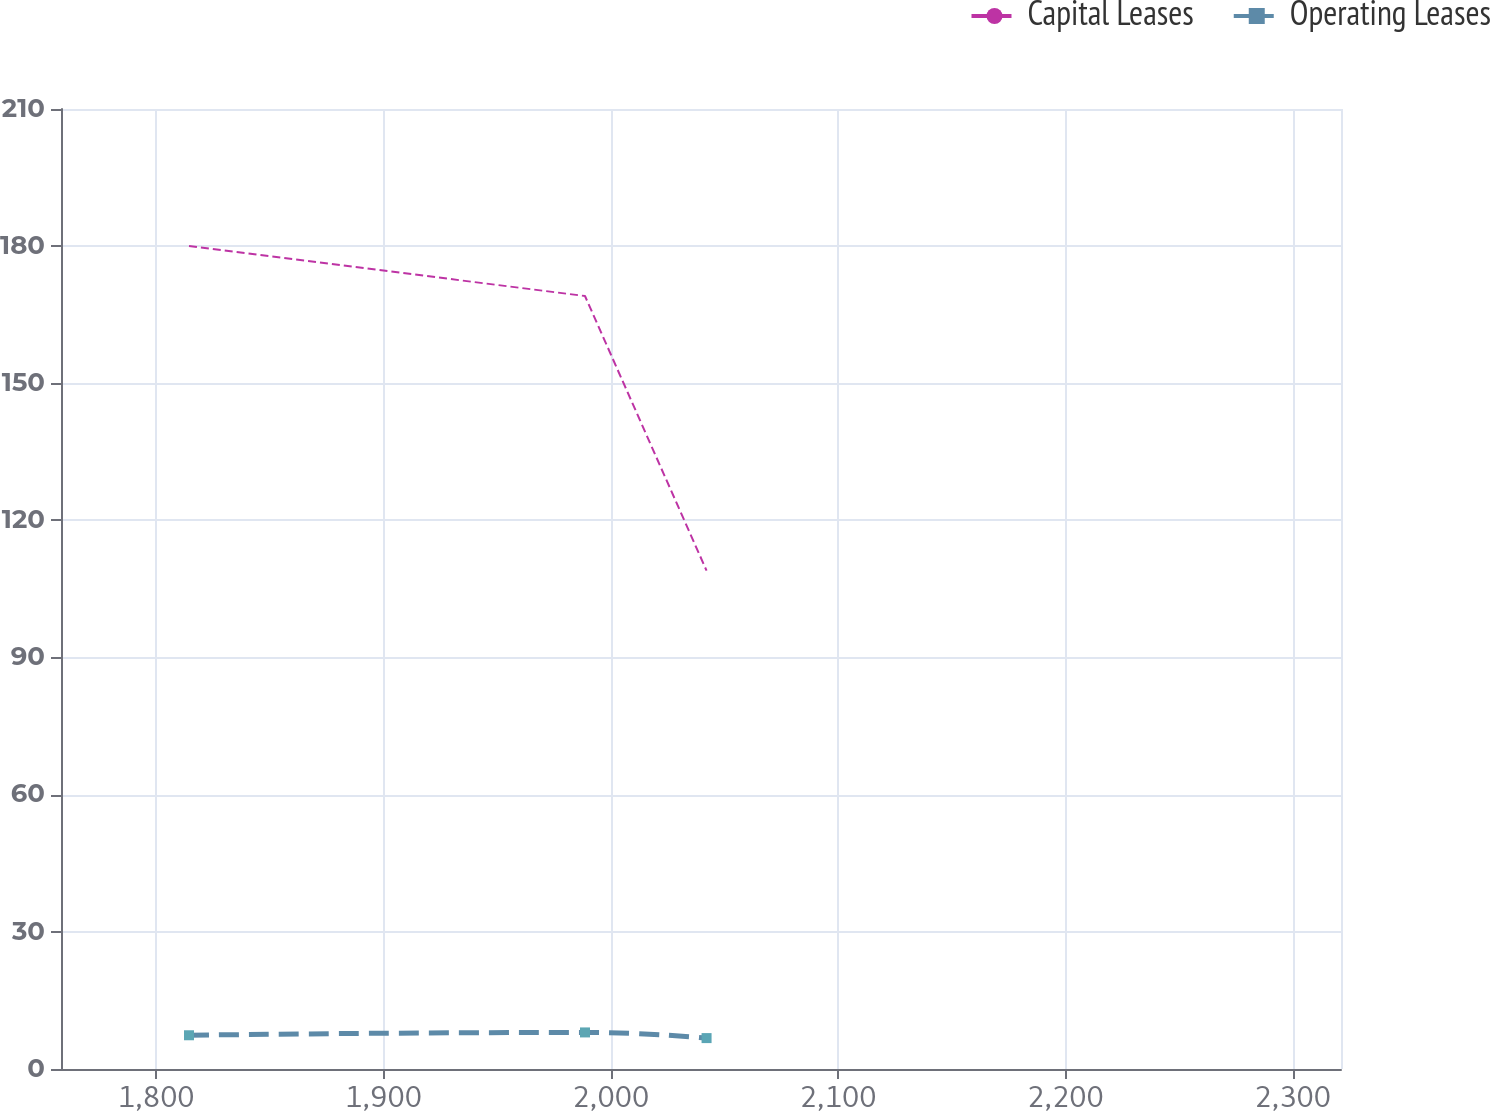<chart> <loc_0><loc_0><loc_500><loc_500><line_chart><ecel><fcel>Capital Leases<fcel>Operating Leases<nl><fcel>1814.45<fcel>180.01<fcel>7.38<nl><fcel>1988.67<fcel>169.09<fcel>8<nl><fcel>2042.16<fcel>109<fcel>6.76<nl><fcel>2324.11<fcel>79.99<fcel>1.86<nl><fcel>2377.6<fcel>69.07<fcel>1.17<nl></chart> 